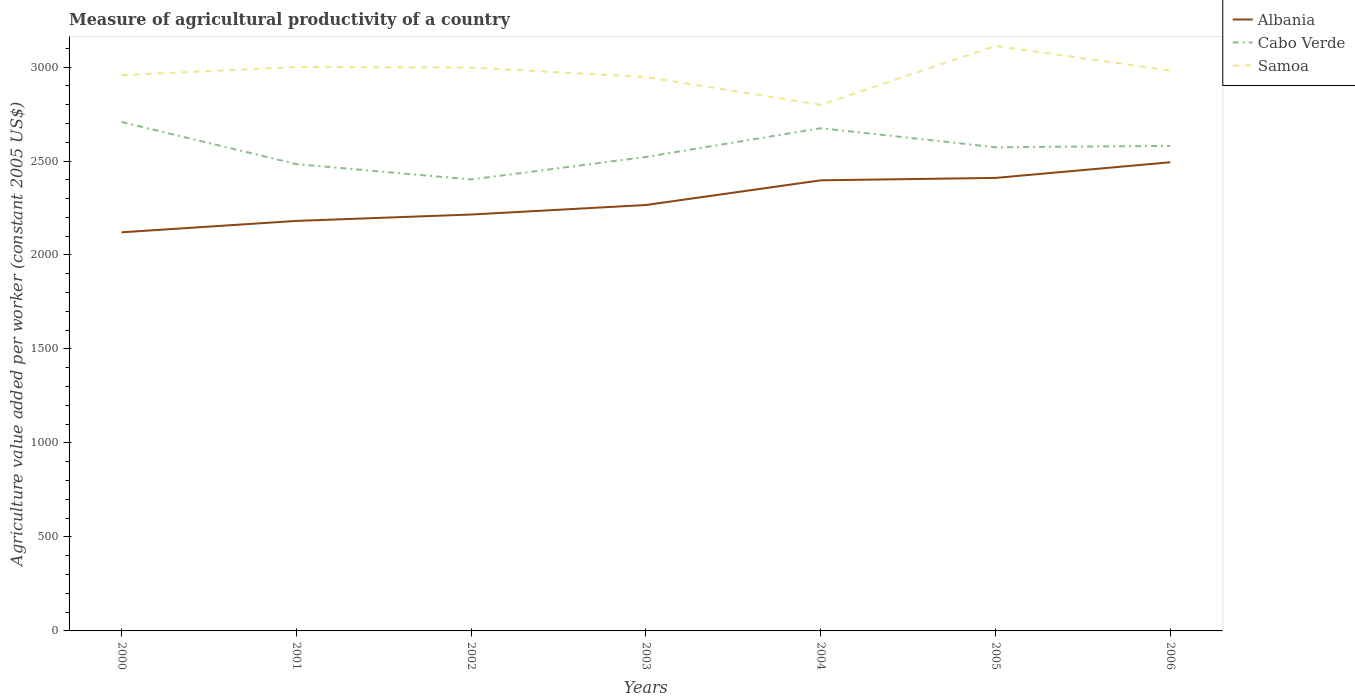Does the line corresponding to Samoa intersect with the line corresponding to Albania?
Keep it short and to the point. No. Across all years, what is the maximum measure of agricultural productivity in Albania?
Provide a short and direct response. 2120.67. What is the total measure of agricultural productivity in Cabo Verde in the graph?
Keep it short and to the point. 81.74. What is the difference between the highest and the second highest measure of agricultural productivity in Samoa?
Provide a short and direct response. 313.85. Is the measure of agricultural productivity in Samoa strictly greater than the measure of agricultural productivity in Albania over the years?
Provide a short and direct response. No. How many years are there in the graph?
Your answer should be very brief. 7. What is the difference between two consecutive major ticks on the Y-axis?
Keep it short and to the point. 500. Does the graph contain any zero values?
Your answer should be very brief. No. Does the graph contain grids?
Provide a short and direct response. No. Where does the legend appear in the graph?
Make the answer very short. Top right. How are the legend labels stacked?
Offer a terse response. Vertical. What is the title of the graph?
Your answer should be compact. Measure of agricultural productivity of a country. What is the label or title of the Y-axis?
Offer a very short reply. Agriculture value added per worker (constant 2005 US$). What is the Agriculture value added per worker (constant 2005 US$) of Albania in 2000?
Make the answer very short. 2120.67. What is the Agriculture value added per worker (constant 2005 US$) of Cabo Verde in 2000?
Provide a succinct answer. 2707.6. What is the Agriculture value added per worker (constant 2005 US$) of Samoa in 2000?
Offer a terse response. 2956.46. What is the Agriculture value added per worker (constant 2005 US$) of Albania in 2001?
Make the answer very short. 2181.33. What is the Agriculture value added per worker (constant 2005 US$) of Cabo Verde in 2001?
Your response must be concise. 2483.66. What is the Agriculture value added per worker (constant 2005 US$) of Samoa in 2001?
Make the answer very short. 3000.37. What is the Agriculture value added per worker (constant 2005 US$) in Albania in 2002?
Give a very brief answer. 2215.33. What is the Agriculture value added per worker (constant 2005 US$) of Cabo Verde in 2002?
Ensure brevity in your answer.  2401.92. What is the Agriculture value added per worker (constant 2005 US$) in Samoa in 2002?
Provide a short and direct response. 2997.24. What is the Agriculture value added per worker (constant 2005 US$) of Albania in 2003?
Your answer should be very brief. 2265.96. What is the Agriculture value added per worker (constant 2005 US$) of Cabo Verde in 2003?
Your response must be concise. 2521.55. What is the Agriculture value added per worker (constant 2005 US$) in Samoa in 2003?
Give a very brief answer. 2946.98. What is the Agriculture value added per worker (constant 2005 US$) in Albania in 2004?
Your answer should be very brief. 2397.31. What is the Agriculture value added per worker (constant 2005 US$) in Cabo Verde in 2004?
Provide a short and direct response. 2674.6. What is the Agriculture value added per worker (constant 2005 US$) of Samoa in 2004?
Keep it short and to the point. 2798.62. What is the Agriculture value added per worker (constant 2005 US$) in Albania in 2005?
Offer a terse response. 2410.11. What is the Agriculture value added per worker (constant 2005 US$) of Cabo Verde in 2005?
Ensure brevity in your answer.  2573.22. What is the Agriculture value added per worker (constant 2005 US$) in Samoa in 2005?
Offer a very short reply. 3112.47. What is the Agriculture value added per worker (constant 2005 US$) in Albania in 2006?
Provide a short and direct response. 2493.36. What is the Agriculture value added per worker (constant 2005 US$) of Cabo Verde in 2006?
Provide a succinct answer. 2580.54. What is the Agriculture value added per worker (constant 2005 US$) in Samoa in 2006?
Offer a very short reply. 2980.96. Across all years, what is the maximum Agriculture value added per worker (constant 2005 US$) of Albania?
Keep it short and to the point. 2493.36. Across all years, what is the maximum Agriculture value added per worker (constant 2005 US$) in Cabo Verde?
Provide a succinct answer. 2707.6. Across all years, what is the maximum Agriculture value added per worker (constant 2005 US$) of Samoa?
Offer a terse response. 3112.47. Across all years, what is the minimum Agriculture value added per worker (constant 2005 US$) in Albania?
Offer a very short reply. 2120.67. Across all years, what is the minimum Agriculture value added per worker (constant 2005 US$) of Cabo Verde?
Provide a succinct answer. 2401.92. Across all years, what is the minimum Agriculture value added per worker (constant 2005 US$) of Samoa?
Provide a short and direct response. 2798.62. What is the total Agriculture value added per worker (constant 2005 US$) of Albania in the graph?
Offer a terse response. 1.61e+04. What is the total Agriculture value added per worker (constant 2005 US$) of Cabo Verde in the graph?
Provide a short and direct response. 1.79e+04. What is the total Agriculture value added per worker (constant 2005 US$) of Samoa in the graph?
Provide a succinct answer. 2.08e+04. What is the difference between the Agriculture value added per worker (constant 2005 US$) of Albania in 2000 and that in 2001?
Ensure brevity in your answer.  -60.67. What is the difference between the Agriculture value added per worker (constant 2005 US$) in Cabo Verde in 2000 and that in 2001?
Offer a very short reply. 223.94. What is the difference between the Agriculture value added per worker (constant 2005 US$) in Samoa in 2000 and that in 2001?
Your answer should be very brief. -43.91. What is the difference between the Agriculture value added per worker (constant 2005 US$) of Albania in 2000 and that in 2002?
Your response must be concise. -94.66. What is the difference between the Agriculture value added per worker (constant 2005 US$) in Cabo Verde in 2000 and that in 2002?
Provide a succinct answer. 305.69. What is the difference between the Agriculture value added per worker (constant 2005 US$) in Samoa in 2000 and that in 2002?
Give a very brief answer. -40.78. What is the difference between the Agriculture value added per worker (constant 2005 US$) of Albania in 2000 and that in 2003?
Give a very brief answer. -145.3. What is the difference between the Agriculture value added per worker (constant 2005 US$) in Cabo Verde in 2000 and that in 2003?
Provide a succinct answer. 186.05. What is the difference between the Agriculture value added per worker (constant 2005 US$) in Samoa in 2000 and that in 2003?
Make the answer very short. 9.49. What is the difference between the Agriculture value added per worker (constant 2005 US$) in Albania in 2000 and that in 2004?
Your answer should be very brief. -276.64. What is the difference between the Agriculture value added per worker (constant 2005 US$) in Cabo Verde in 2000 and that in 2004?
Make the answer very short. 33.01. What is the difference between the Agriculture value added per worker (constant 2005 US$) of Samoa in 2000 and that in 2004?
Offer a terse response. 157.85. What is the difference between the Agriculture value added per worker (constant 2005 US$) in Albania in 2000 and that in 2005?
Make the answer very short. -289.45. What is the difference between the Agriculture value added per worker (constant 2005 US$) in Cabo Verde in 2000 and that in 2005?
Offer a terse response. 134.38. What is the difference between the Agriculture value added per worker (constant 2005 US$) in Samoa in 2000 and that in 2005?
Give a very brief answer. -156. What is the difference between the Agriculture value added per worker (constant 2005 US$) in Albania in 2000 and that in 2006?
Your answer should be very brief. -372.69. What is the difference between the Agriculture value added per worker (constant 2005 US$) of Cabo Verde in 2000 and that in 2006?
Your answer should be very brief. 127.06. What is the difference between the Agriculture value added per worker (constant 2005 US$) of Samoa in 2000 and that in 2006?
Make the answer very short. -24.49. What is the difference between the Agriculture value added per worker (constant 2005 US$) in Albania in 2001 and that in 2002?
Make the answer very short. -34. What is the difference between the Agriculture value added per worker (constant 2005 US$) in Cabo Verde in 2001 and that in 2002?
Make the answer very short. 81.74. What is the difference between the Agriculture value added per worker (constant 2005 US$) in Samoa in 2001 and that in 2002?
Offer a very short reply. 3.13. What is the difference between the Agriculture value added per worker (constant 2005 US$) of Albania in 2001 and that in 2003?
Your answer should be compact. -84.63. What is the difference between the Agriculture value added per worker (constant 2005 US$) in Cabo Verde in 2001 and that in 2003?
Give a very brief answer. -37.89. What is the difference between the Agriculture value added per worker (constant 2005 US$) of Samoa in 2001 and that in 2003?
Ensure brevity in your answer.  53.4. What is the difference between the Agriculture value added per worker (constant 2005 US$) in Albania in 2001 and that in 2004?
Your response must be concise. -215.97. What is the difference between the Agriculture value added per worker (constant 2005 US$) of Cabo Verde in 2001 and that in 2004?
Keep it short and to the point. -190.94. What is the difference between the Agriculture value added per worker (constant 2005 US$) in Samoa in 2001 and that in 2004?
Offer a very short reply. 201.76. What is the difference between the Agriculture value added per worker (constant 2005 US$) of Albania in 2001 and that in 2005?
Your answer should be compact. -228.78. What is the difference between the Agriculture value added per worker (constant 2005 US$) in Cabo Verde in 2001 and that in 2005?
Offer a very short reply. -89.56. What is the difference between the Agriculture value added per worker (constant 2005 US$) in Samoa in 2001 and that in 2005?
Ensure brevity in your answer.  -112.1. What is the difference between the Agriculture value added per worker (constant 2005 US$) in Albania in 2001 and that in 2006?
Make the answer very short. -312.02. What is the difference between the Agriculture value added per worker (constant 2005 US$) of Cabo Verde in 2001 and that in 2006?
Give a very brief answer. -96.88. What is the difference between the Agriculture value added per worker (constant 2005 US$) of Samoa in 2001 and that in 2006?
Keep it short and to the point. 19.42. What is the difference between the Agriculture value added per worker (constant 2005 US$) of Albania in 2002 and that in 2003?
Provide a short and direct response. -50.63. What is the difference between the Agriculture value added per worker (constant 2005 US$) in Cabo Verde in 2002 and that in 2003?
Provide a short and direct response. -119.63. What is the difference between the Agriculture value added per worker (constant 2005 US$) in Samoa in 2002 and that in 2003?
Your answer should be compact. 50.26. What is the difference between the Agriculture value added per worker (constant 2005 US$) of Albania in 2002 and that in 2004?
Offer a very short reply. -181.98. What is the difference between the Agriculture value added per worker (constant 2005 US$) in Cabo Verde in 2002 and that in 2004?
Make the answer very short. -272.68. What is the difference between the Agriculture value added per worker (constant 2005 US$) of Samoa in 2002 and that in 2004?
Offer a very short reply. 198.62. What is the difference between the Agriculture value added per worker (constant 2005 US$) in Albania in 2002 and that in 2005?
Provide a succinct answer. -194.78. What is the difference between the Agriculture value added per worker (constant 2005 US$) of Cabo Verde in 2002 and that in 2005?
Provide a short and direct response. -171.3. What is the difference between the Agriculture value added per worker (constant 2005 US$) of Samoa in 2002 and that in 2005?
Your answer should be very brief. -115.23. What is the difference between the Agriculture value added per worker (constant 2005 US$) of Albania in 2002 and that in 2006?
Keep it short and to the point. -278.03. What is the difference between the Agriculture value added per worker (constant 2005 US$) in Cabo Verde in 2002 and that in 2006?
Provide a succinct answer. -178.62. What is the difference between the Agriculture value added per worker (constant 2005 US$) of Samoa in 2002 and that in 2006?
Make the answer very short. 16.28. What is the difference between the Agriculture value added per worker (constant 2005 US$) in Albania in 2003 and that in 2004?
Your response must be concise. -131.34. What is the difference between the Agriculture value added per worker (constant 2005 US$) of Cabo Verde in 2003 and that in 2004?
Your answer should be very brief. -153.05. What is the difference between the Agriculture value added per worker (constant 2005 US$) in Samoa in 2003 and that in 2004?
Provide a succinct answer. 148.36. What is the difference between the Agriculture value added per worker (constant 2005 US$) of Albania in 2003 and that in 2005?
Your answer should be very brief. -144.15. What is the difference between the Agriculture value added per worker (constant 2005 US$) in Cabo Verde in 2003 and that in 2005?
Your answer should be very brief. -51.67. What is the difference between the Agriculture value added per worker (constant 2005 US$) of Samoa in 2003 and that in 2005?
Give a very brief answer. -165.49. What is the difference between the Agriculture value added per worker (constant 2005 US$) of Albania in 2003 and that in 2006?
Your answer should be very brief. -227.39. What is the difference between the Agriculture value added per worker (constant 2005 US$) in Cabo Verde in 2003 and that in 2006?
Your answer should be very brief. -58.99. What is the difference between the Agriculture value added per worker (constant 2005 US$) of Samoa in 2003 and that in 2006?
Ensure brevity in your answer.  -33.98. What is the difference between the Agriculture value added per worker (constant 2005 US$) of Albania in 2004 and that in 2005?
Your answer should be very brief. -12.8. What is the difference between the Agriculture value added per worker (constant 2005 US$) in Cabo Verde in 2004 and that in 2005?
Your response must be concise. 101.38. What is the difference between the Agriculture value added per worker (constant 2005 US$) in Samoa in 2004 and that in 2005?
Your answer should be compact. -313.85. What is the difference between the Agriculture value added per worker (constant 2005 US$) in Albania in 2004 and that in 2006?
Ensure brevity in your answer.  -96.05. What is the difference between the Agriculture value added per worker (constant 2005 US$) of Cabo Verde in 2004 and that in 2006?
Give a very brief answer. 94.06. What is the difference between the Agriculture value added per worker (constant 2005 US$) of Samoa in 2004 and that in 2006?
Keep it short and to the point. -182.34. What is the difference between the Agriculture value added per worker (constant 2005 US$) of Albania in 2005 and that in 2006?
Keep it short and to the point. -83.24. What is the difference between the Agriculture value added per worker (constant 2005 US$) in Cabo Verde in 2005 and that in 2006?
Provide a succinct answer. -7.32. What is the difference between the Agriculture value added per worker (constant 2005 US$) of Samoa in 2005 and that in 2006?
Provide a succinct answer. 131.51. What is the difference between the Agriculture value added per worker (constant 2005 US$) in Albania in 2000 and the Agriculture value added per worker (constant 2005 US$) in Cabo Verde in 2001?
Offer a very short reply. -362.99. What is the difference between the Agriculture value added per worker (constant 2005 US$) in Albania in 2000 and the Agriculture value added per worker (constant 2005 US$) in Samoa in 2001?
Give a very brief answer. -879.71. What is the difference between the Agriculture value added per worker (constant 2005 US$) of Cabo Verde in 2000 and the Agriculture value added per worker (constant 2005 US$) of Samoa in 2001?
Ensure brevity in your answer.  -292.77. What is the difference between the Agriculture value added per worker (constant 2005 US$) of Albania in 2000 and the Agriculture value added per worker (constant 2005 US$) of Cabo Verde in 2002?
Your answer should be very brief. -281.25. What is the difference between the Agriculture value added per worker (constant 2005 US$) of Albania in 2000 and the Agriculture value added per worker (constant 2005 US$) of Samoa in 2002?
Ensure brevity in your answer.  -876.57. What is the difference between the Agriculture value added per worker (constant 2005 US$) of Cabo Verde in 2000 and the Agriculture value added per worker (constant 2005 US$) of Samoa in 2002?
Keep it short and to the point. -289.64. What is the difference between the Agriculture value added per worker (constant 2005 US$) of Albania in 2000 and the Agriculture value added per worker (constant 2005 US$) of Cabo Verde in 2003?
Make the answer very short. -400.88. What is the difference between the Agriculture value added per worker (constant 2005 US$) of Albania in 2000 and the Agriculture value added per worker (constant 2005 US$) of Samoa in 2003?
Your response must be concise. -826.31. What is the difference between the Agriculture value added per worker (constant 2005 US$) in Cabo Verde in 2000 and the Agriculture value added per worker (constant 2005 US$) in Samoa in 2003?
Your answer should be compact. -239.38. What is the difference between the Agriculture value added per worker (constant 2005 US$) in Albania in 2000 and the Agriculture value added per worker (constant 2005 US$) in Cabo Verde in 2004?
Provide a succinct answer. -553.93. What is the difference between the Agriculture value added per worker (constant 2005 US$) of Albania in 2000 and the Agriculture value added per worker (constant 2005 US$) of Samoa in 2004?
Offer a very short reply. -677.95. What is the difference between the Agriculture value added per worker (constant 2005 US$) in Cabo Verde in 2000 and the Agriculture value added per worker (constant 2005 US$) in Samoa in 2004?
Your answer should be very brief. -91.02. What is the difference between the Agriculture value added per worker (constant 2005 US$) in Albania in 2000 and the Agriculture value added per worker (constant 2005 US$) in Cabo Verde in 2005?
Offer a very short reply. -452.55. What is the difference between the Agriculture value added per worker (constant 2005 US$) of Albania in 2000 and the Agriculture value added per worker (constant 2005 US$) of Samoa in 2005?
Keep it short and to the point. -991.8. What is the difference between the Agriculture value added per worker (constant 2005 US$) in Cabo Verde in 2000 and the Agriculture value added per worker (constant 2005 US$) in Samoa in 2005?
Your response must be concise. -404.87. What is the difference between the Agriculture value added per worker (constant 2005 US$) in Albania in 2000 and the Agriculture value added per worker (constant 2005 US$) in Cabo Verde in 2006?
Ensure brevity in your answer.  -459.87. What is the difference between the Agriculture value added per worker (constant 2005 US$) in Albania in 2000 and the Agriculture value added per worker (constant 2005 US$) in Samoa in 2006?
Your answer should be very brief. -860.29. What is the difference between the Agriculture value added per worker (constant 2005 US$) of Cabo Verde in 2000 and the Agriculture value added per worker (constant 2005 US$) of Samoa in 2006?
Your response must be concise. -273.35. What is the difference between the Agriculture value added per worker (constant 2005 US$) of Albania in 2001 and the Agriculture value added per worker (constant 2005 US$) of Cabo Verde in 2002?
Offer a very short reply. -220.58. What is the difference between the Agriculture value added per worker (constant 2005 US$) in Albania in 2001 and the Agriculture value added per worker (constant 2005 US$) in Samoa in 2002?
Ensure brevity in your answer.  -815.91. What is the difference between the Agriculture value added per worker (constant 2005 US$) in Cabo Verde in 2001 and the Agriculture value added per worker (constant 2005 US$) in Samoa in 2002?
Make the answer very short. -513.58. What is the difference between the Agriculture value added per worker (constant 2005 US$) in Albania in 2001 and the Agriculture value added per worker (constant 2005 US$) in Cabo Verde in 2003?
Your response must be concise. -340.21. What is the difference between the Agriculture value added per worker (constant 2005 US$) in Albania in 2001 and the Agriculture value added per worker (constant 2005 US$) in Samoa in 2003?
Give a very brief answer. -765.64. What is the difference between the Agriculture value added per worker (constant 2005 US$) of Cabo Verde in 2001 and the Agriculture value added per worker (constant 2005 US$) of Samoa in 2003?
Provide a short and direct response. -463.32. What is the difference between the Agriculture value added per worker (constant 2005 US$) of Albania in 2001 and the Agriculture value added per worker (constant 2005 US$) of Cabo Verde in 2004?
Your response must be concise. -493.26. What is the difference between the Agriculture value added per worker (constant 2005 US$) of Albania in 2001 and the Agriculture value added per worker (constant 2005 US$) of Samoa in 2004?
Ensure brevity in your answer.  -617.28. What is the difference between the Agriculture value added per worker (constant 2005 US$) in Cabo Verde in 2001 and the Agriculture value added per worker (constant 2005 US$) in Samoa in 2004?
Make the answer very short. -314.96. What is the difference between the Agriculture value added per worker (constant 2005 US$) of Albania in 2001 and the Agriculture value added per worker (constant 2005 US$) of Cabo Verde in 2005?
Keep it short and to the point. -391.88. What is the difference between the Agriculture value added per worker (constant 2005 US$) of Albania in 2001 and the Agriculture value added per worker (constant 2005 US$) of Samoa in 2005?
Provide a short and direct response. -931.13. What is the difference between the Agriculture value added per worker (constant 2005 US$) of Cabo Verde in 2001 and the Agriculture value added per worker (constant 2005 US$) of Samoa in 2005?
Your answer should be very brief. -628.81. What is the difference between the Agriculture value added per worker (constant 2005 US$) in Albania in 2001 and the Agriculture value added per worker (constant 2005 US$) in Cabo Verde in 2006?
Ensure brevity in your answer.  -399.2. What is the difference between the Agriculture value added per worker (constant 2005 US$) of Albania in 2001 and the Agriculture value added per worker (constant 2005 US$) of Samoa in 2006?
Provide a succinct answer. -799.62. What is the difference between the Agriculture value added per worker (constant 2005 US$) of Cabo Verde in 2001 and the Agriculture value added per worker (constant 2005 US$) of Samoa in 2006?
Your answer should be compact. -497.3. What is the difference between the Agriculture value added per worker (constant 2005 US$) in Albania in 2002 and the Agriculture value added per worker (constant 2005 US$) in Cabo Verde in 2003?
Make the answer very short. -306.22. What is the difference between the Agriculture value added per worker (constant 2005 US$) in Albania in 2002 and the Agriculture value added per worker (constant 2005 US$) in Samoa in 2003?
Your answer should be very brief. -731.65. What is the difference between the Agriculture value added per worker (constant 2005 US$) in Cabo Verde in 2002 and the Agriculture value added per worker (constant 2005 US$) in Samoa in 2003?
Provide a succinct answer. -545.06. What is the difference between the Agriculture value added per worker (constant 2005 US$) in Albania in 2002 and the Agriculture value added per worker (constant 2005 US$) in Cabo Verde in 2004?
Offer a terse response. -459.26. What is the difference between the Agriculture value added per worker (constant 2005 US$) of Albania in 2002 and the Agriculture value added per worker (constant 2005 US$) of Samoa in 2004?
Give a very brief answer. -583.29. What is the difference between the Agriculture value added per worker (constant 2005 US$) of Cabo Verde in 2002 and the Agriculture value added per worker (constant 2005 US$) of Samoa in 2004?
Your answer should be very brief. -396.7. What is the difference between the Agriculture value added per worker (constant 2005 US$) of Albania in 2002 and the Agriculture value added per worker (constant 2005 US$) of Cabo Verde in 2005?
Your answer should be very brief. -357.89. What is the difference between the Agriculture value added per worker (constant 2005 US$) of Albania in 2002 and the Agriculture value added per worker (constant 2005 US$) of Samoa in 2005?
Your answer should be very brief. -897.14. What is the difference between the Agriculture value added per worker (constant 2005 US$) in Cabo Verde in 2002 and the Agriculture value added per worker (constant 2005 US$) in Samoa in 2005?
Offer a terse response. -710.55. What is the difference between the Agriculture value added per worker (constant 2005 US$) of Albania in 2002 and the Agriculture value added per worker (constant 2005 US$) of Cabo Verde in 2006?
Give a very brief answer. -365.21. What is the difference between the Agriculture value added per worker (constant 2005 US$) in Albania in 2002 and the Agriculture value added per worker (constant 2005 US$) in Samoa in 2006?
Your answer should be compact. -765.62. What is the difference between the Agriculture value added per worker (constant 2005 US$) of Cabo Verde in 2002 and the Agriculture value added per worker (constant 2005 US$) of Samoa in 2006?
Your response must be concise. -579.04. What is the difference between the Agriculture value added per worker (constant 2005 US$) in Albania in 2003 and the Agriculture value added per worker (constant 2005 US$) in Cabo Verde in 2004?
Provide a succinct answer. -408.63. What is the difference between the Agriculture value added per worker (constant 2005 US$) of Albania in 2003 and the Agriculture value added per worker (constant 2005 US$) of Samoa in 2004?
Ensure brevity in your answer.  -532.65. What is the difference between the Agriculture value added per worker (constant 2005 US$) of Cabo Verde in 2003 and the Agriculture value added per worker (constant 2005 US$) of Samoa in 2004?
Make the answer very short. -277.07. What is the difference between the Agriculture value added per worker (constant 2005 US$) in Albania in 2003 and the Agriculture value added per worker (constant 2005 US$) in Cabo Verde in 2005?
Make the answer very short. -307.26. What is the difference between the Agriculture value added per worker (constant 2005 US$) of Albania in 2003 and the Agriculture value added per worker (constant 2005 US$) of Samoa in 2005?
Ensure brevity in your answer.  -846.51. What is the difference between the Agriculture value added per worker (constant 2005 US$) of Cabo Verde in 2003 and the Agriculture value added per worker (constant 2005 US$) of Samoa in 2005?
Make the answer very short. -590.92. What is the difference between the Agriculture value added per worker (constant 2005 US$) in Albania in 2003 and the Agriculture value added per worker (constant 2005 US$) in Cabo Verde in 2006?
Offer a very short reply. -314.57. What is the difference between the Agriculture value added per worker (constant 2005 US$) of Albania in 2003 and the Agriculture value added per worker (constant 2005 US$) of Samoa in 2006?
Your answer should be very brief. -714.99. What is the difference between the Agriculture value added per worker (constant 2005 US$) in Cabo Verde in 2003 and the Agriculture value added per worker (constant 2005 US$) in Samoa in 2006?
Your answer should be compact. -459.41. What is the difference between the Agriculture value added per worker (constant 2005 US$) in Albania in 2004 and the Agriculture value added per worker (constant 2005 US$) in Cabo Verde in 2005?
Your answer should be compact. -175.91. What is the difference between the Agriculture value added per worker (constant 2005 US$) in Albania in 2004 and the Agriculture value added per worker (constant 2005 US$) in Samoa in 2005?
Offer a terse response. -715.16. What is the difference between the Agriculture value added per worker (constant 2005 US$) of Cabo Verde in 2004 and the Agriculture value added per worker (constant 2005 US$) of Samoa in 2005?
Provide a succinct answer. -437.87. What is the difference between the Agriculture value added per worker (constant 2005 US$) in Albania in 2004 and the Agriculture value added per worker (constant 2005 US$) in Cabo Verde in 2006?
Keep it short and to the point. -183.23. What is the difference between the Agriculture value added per worker (constant 2005 US$) of Albania in 2004 and the Agriculture value added per worker (constant 2005 US$) of Samoa in 2006?
Make the answer very short. -583.65. What is the difference between the Agriculture value added per worker (constant 2005 US$) in Cabo Verde in 2004 and the Agriculture value added per worker (constant 2005 US$) in Samoa in 2006?
Give a very brief answer. -306.36. What is the difference between the Agriculture value added per worker (constant 2005 US$) in Albania in 2005 and the Agriculture value added per worker (constant 2005 US$) in Cabo Verde in 2006?
Give a very brief answer. -170.42. What is the difference between the Agriculture value added per worker (constant 2005 US$) in Albania in 2005 and the Agriculture value added per worker (constant 2005 US$) in Samoa in 2006?
Your answer should be compact. -570.84. What is the difference between the Agriculture value added per worker (constant 2005 US$) of Cabo Verde in 2005 and the Agriculture value added per worker (constant 2005 US$) of Samoa in 2006?
Your answer should be very brief. -407.74. What is the average Agriculture value added per worker (constant 2005 US$) of Albania per year?
Make the answer very short. 2297.73. What is the average Agriculture value added per worker (constant 2005 US$) in Cabo Verde per year?
Offer a terse response. 2563.3. What is the average Agriculture value added per worker (constant 2005 US$) of Samoa per year?
Your answer should be very brief. 2970.44. In the year 2000, what is the difference between the Agriculture value added per worker (constant 2005 US$) of Albania and Agriculture value added per worker (constant 2005 US$) of Cabo Verde?
Offer a very short reply. -586.93. In the year 2000, what is the difference between the Agriculture value added per worker (constant 2005 US$) in Albania and Agriculture value added per worker (constant 2005 US$) in Samoa?
Your answer should be compact. -835.8. In the year 2000, what is the difference between the Agriculture value added per worker (constant 2005 US$) in Cabo Verde and Agriculture value added per worker (constant 2005 US$) in Samoa?
Ensure brevity in your answer.  -248.86. In the year 2001, what is the difference between the Agriculture value added per worker (constant 2005 US$) of Albania and Agriculture value added per worker (constant 2005 US$) of Cabo Verde?
Give a very brief answer. -302.32. In the year 2001, what is the difference between the Agriculture value added per worker (constant 2005 US$) of Albania and Agriculture value added per worker (constant 2005 US$) of Samoa?
Your answer should be compact. -819.04. In the year 2001, what is the difference between the Agriculture value added per worker (constant 2005 US$) of Cabo Verde and Agriculture value added per worker (constant 2005 US$) of Samoa?
Offer a terse response. -516.72. In the year 2002, what is the difference between the Agriculture value added per worker (constant 2005 US$) of Albania and Agriculture value added per worker (constant 2005 US$) of Cabo Verde?
Offer a very short reply. -186.58. In the year 2002, what is the difference between the Agriculture value added per worker (constant 2005 US$) in Albania and Agriculture value added per worker (constant 2005 US$) in Samoa?
Ensure brevity in your answer.  -781.91. In the year 2002, what is the difference between the Agriculture value added per worker (constant 2005 US$) of Cabo Verde and Agriculture value added per worker (constant 2005 US$) of Samoa?
Offer a terse response. -595.33. In the year 2003, what is the difference between the Agriculture value added per worker (constant 2005 US$) of Albania and Agriculture value added per worker (constant 2005 US$) of Cabo Verde?
Provide a short and direct response. -255.58. In the year 2003, what is the difference between the Agriculture value added per worker (constant 2005 US$) in Albania and Agriculture value added per worker (constant 2005 US$) in Samoa?
Offer a very short reply. -681.01. In the year 2003, what is the difference between the Agriculture value added per worker (constant 2005 US$) of Cabo Verde and Agriculture value added per worker (constant 2005 US$) of Samoa?
Ensure brevity in your answer.  -425.43. In the year 2004, what is the difference between the Agriculture value added per worker (constant 2005 US$) in Albania and Agriculture value added per worker (constant 2005 US$) in Cabo Verde?
Your answer should be very brief. -277.29. In the year 2004, what is the difference between the Agriculture value added per worker (constant 2005 US$) of Albania and Agriculture value added per worker (constant 2005 US$) of Samoa?
Give a very brief answer. -401.31. In the year 2004, what is the difference between the Agriculture value added per worker (constant 2005 US$) in Cabo Verde and Agriculture value added per worker (constant 2005 US$) in Samoa?
Provide a short and direct response. -124.02. In the year 2005, what is the difference between the Agriculture value added per worker (constant 2005 US$) in Albania and Agriculture value added per worker (constant 2005 US$) in Cabo Verde?
Make the answer very short. -163.11. In the year 2005, what is the difference between the Agriculture value added per worker (constant 2005 US$) of Albania and Agriculture value added per worker (constant 2005 US$) of Samoa?
Make the answer very short. -702.36. In the year 2005, what is the difference between the Agriculture value added per worker (constant 2005 US$) of Cabo Verde and Agriculture value added per worker (constant 2005 US$) of Samoa?
Provide a short and direct response. -539.25. In the year 2006, what is the difference between the Agriculture value added per worker (constant 2005 US$) of Albania and Agriculture value added per worker (constant 2005 US$) of Cabo Verde?
Provide a succinct answer. -87.18. In the year 2006, what is the difference between the Agriculture value added per worker (constant 2005 US$) in Albania and Agriculture value added per worker (constant 2005 US$) in Samoa?
Your response must be concise. -487.6. In the year 2006, what is the difference between the Agriculture value added per worker (constant 2005 US$) in Cabo Verde and Agriculture value added per worker (constant 2005 US$) in Samoa?
Offer a very short reply. -400.42. What is the ratio of the Agriculture value added per worker (constant 2005 US$) in Albania in 2000 to that in 2001?
Keep it short and to the point. 0.97. What is the ratio of the Agriculture value added per worker (constant 2005 US$) in Cabo Verde in 2000 to that in 2001?
Make the answer very short. 1.09. What is the ratio of the Agriculture value added per worker (constant 2005 US$) of Samoa in 2000 to that in 2001?
Your answer should be compact. 0.99. What is the ratio of the Agriculture value added per worker (constant 2005 US$) of Albania in 2000 to that in 2002?
Ensure brevity in your answer.  0.96. What is the ratio of the Agriculture value added per worker (constant 2005 US$) of Cabo Verde in 2000 to that in 2002?
Ensure brevity in your answer.  1.13. What is the ratio of the Agriculture value added per worker (constant 2005 US$) in Samoa in 2000 to that in 2002?
Provide a short and direct response. 0.99. What is the ratio of the Agriculture value added per worker (constant 2005 US$) of Albania in 2000 to that in 2003?
Offer a very short reply. 0.94. What is the ratio of the Agriculture value added per worker (constant 2005 US$) in Cabo Verde in 2000 to that in 2003?
Your answer should be very brief. 1.07. What is the ratio of the Agriculture value added per worker (constant 2005 US$) in Samoa in 2000 to that in 2003?
Your answer should be very brief. 1. What is the ratio of the Agriculture value added per worker (constant 2005 US$) of Albania in 2000 to that in 2004?
Your response must be concise. 0.88. What is the ratio of the Agriculture value added per worker (constant 2005 US$) of Cabo Verde in 2000 to that in 2004?
Make the answer very short. 1.01. What is the ratio of the Agriculture value added per worker (constant 2005 US$) in Samoa in 2000 to that in 2004?
Offer a very short reply. 1.06. What is the ratio of the Agriculture value added per worker (constant 2005 US$) of Albania in 2000 to that in 2005?
Keep it short and to the point. 0.88. What is the ratio of the Agriculture value added per worker (constant 2005 US$) in Cabo Verde in 2000 to that in 2005?
Provide a short and direct response. 1.05. What is the ratio of the Agriculture value added per worker (constant 2005 US$) of Samoa in 2000 to that in 2005?
Ensure brevity in your answer.  0.95. What is the ratio of the Agriculture value added per worker (constant 2005 US$) of Albania in 2000 to that in 2006?
Your answer should be very brief. 0.85. What is the ratio of the Agriculture value added per worker (constant 2005 US$) in Cabo Verde in 2000 to that in 2006?
Provide a succinct answer. 1.05. What is the ratio of the Agriculture value added per worker (constant 2005 US$) in Samoa in 2000 to that in 2006?
Offer a very short reply. 0.99. What is the ratio of the Agriculture value added per worker (constant 2005 US$) of Albania in 2001 to that in 2002?
Make the answer very short. 0.98. What is the ratio of the Agriculture value added per worker (constant 2005 US$) in Cabo Verde in 2001 to that in 2002?
Offer a very short reply. 1.03. What is the ratio of the Agriculture value added per worker (constant 2005 US$) of Samoa in 2001 to that in 2002?
Give a very brief answer. 1. What is the ratio of the Agriculture value added per worker (constant 2005 US$) in Albania in 2001 to that in 2003?
Your response must be concise. 0.96. What is the ratio of the Agriculture value added per worker (constant 2005 US$) in Samoa in 2001 to that in 2003?
Provide a succinct answer. 1.02. What is the ratio of the Agriculture value added per worker (constant 2005 US$) in Albania in 2001 to that in 2004?
Give a very brief answer. 0.91. What is the ratio of the Agriculture value added per worker (constant 2005 US$) in Cabo Verde in 2001 to that in 2004?
Your answer should be compact. 0.93. What is the ratio of the Agriculture value added per worker (constant 2005 US$) of Samoa in 2001 to that in 2004?
Provide a short and direct response. 1.07. What is the ratio of the Agriculture value added per worker (constant 2005 US$) in Albania in 2001 to that in 2005?
Keep it short and to the point. 0.91. What is the ratio of the Agriculture value added per worker (constant 2005 US$) in Cabo Verde in 2001 to that in 2005?
Offer a very short reply. 0.97. What is the ratio of the Agriculture value added per worker (constant 2005 US$) of Albania in 2001 to that in 2006?
Your answer should be compact. 0.87. What is the ratio of the Agriculture value added per worker (constant 2005 US$) of Cabo Verde in 2001 to that in 2006?
Provide a succinct answer. 0.96. What is the ratio of the Agriculture value added per worker (constant 2005 US$) in Samoa in 2001 to that in 2006?
Your answer should be compact. 1.01. What is the ratio of the Agriculture value added per worker (constant 2005 US$) in Albania in 2002 to that in 2003?
Make the answer very short. 0.98. What is the ratio of the Agriculture value added per worker (constant 2005 US$) in Cabo Verde in 2002 to that in 2003?
Make the answer very short. 0.95. What is the ratio of the Agriculture value added per worker (constant 2005 US$) in Samoa in 2002 to that in 2003?
Your response must be concise. 1.02. What is the ratio of the Agriculture value added per worker (constant 2005 US$) in Albania in 2002 to that in 2004?
Your answer should be very brief. 0.92. What is the ratio of the Agriculture value added per worker (constant 2005 US$) in Cabo Verde in 2002 to that in 2004?
Make the answer very short. 0.9. What is the ratio of the Agriculture value added per worker (constant 2005 US$) in Samoa in 2002 to that in 2004?
Provide a succinct answer. 1.07. What is the ratio of the Agriculture value added per worker (constant 2005 US$) in Albania in 2002 to that in 2005?
Offer a very short reply. 0.92. What is the ratio of the Agriculture value added per worker (constant 2005 US$) of Cabo Verde in 2002 to that in 2005?
Your answer should be very brief. 0.93. What is the ratio of the Agriculture value added per worker (constant 2005 US$) in Samoa in 2002 to that in 2005?
Provide a succinct answer. 0.96. What is the ratio of the Agriculture value added per worker (constant 2005 US$) of Albania in 2002 to that in 2006?
Offer a terse response. 0.89. What is the ratio of the Agriculture value added per worker (constant 2005 US$) in Cabo Verde in 2002 to that in 2006?
Make the answer very short. 0.93. What is the ratio of the Agriculture value added per worker (constant 2005 US$) of Samoa in 2002 to that in 2006?
Make the answer very short. 1.01. What is the ratio of the Agriculture value added per worker (constant 2005 US$) in Albania in 2003 to that in 2004?
Make the answer very short. 0.95. What is the ratio of the Agriculture value added per worker (constant 2005 US$) of Cabo Verde in 2003 to that in 2004?
Provide a short and direct response. 0.94. What is the ratio of the Agriculture value added per worker (constant 2005 US$) in Samoa in 2003 to that in 2004?
Your answer should be very brief. 1.05. What is the ratio of the Agriculture value added per worker (constant 2005 US$) of Albania in 2003 to that in 2005?
Your answer should be compact. 0.94. What is the ratio of the Agriculture value added per worker (constant 2005 US$) in Cabo Verde in 2003 to that in 2005?
Provide a succinct answer. 0.98. What is the ratio of the Agriculture value added per worker (constant 2005 US$) of Samoa in 2003 to that in 2005?
Make the answer very short. 0.95. What is the ratio of the Agriculture value added per worker (constant 2005 US$) in Albania in 2003 to that in 2006?
Offer a very short reply. 0.91. What is the ratio of the Agriculture value added per worker (constant 2005 US$) in Cabo Verde in 2003 to that in 2006?
Your response must be concise. 0.98. What is the ratio of the Agriculture value added per worker (constant 2005 US$) in Cabo Verde in 2004 to that in 2005?
Your response must be concise. 1.04. What is the ratio of the Agriculture value added per worker (constant 2005 US$) of Samoa in 2004 to that in 2005?
Offer a very short reply. 0.9. What is the ratio of the Agriculture value added per worker (constant 2005 US$) of Albania in 2004 to that in 2006?
Provide a succinct answer. 0.96. What is the ratio of the Agriculture value added per worker (constant 2005 US$) in Cabo Verde in 2004 to that in 2006?
Ensure brevity in your answer.  1.04. What is the ratio of the Agriculture value added per worker (constant 2005 US$) in Samoa in 2004 to that in 2006?
Give a very brief answer. 0.94. What is the ratio of the Agriculture value added per worker (constant 2005 US$) in Albania in 2005 to that in 2006?
Keep it short and to the point. 0.97. What is the ratio of the Agriculture value added per worker (constant 2005 US$) of Cabo Verde in 2005 to that in 2006?
Make the answer very short. 1. What is the ratio of the Agriculture value added per worker (constant 2005 US$) in Samoa in 2005 to that in 2006?
Your answer should be very brief. 1.04. What is the difference between the highest and the second highest Agriculture value added per worker (constant 2005 US$) of Albania?
Give a very brief answer. 83.24. What is the difference between the highest and the second highest Agriculture value added per worker (constant 2005 US$) in Cabo Verde?
Your response must be concise. 33.01. What is the difference between the highest and the second highest Agriculture value added per worker (constant 2005 US$) in Samoa?
Provide a succinct answer. 112.1. What is the difference between the highest and the lowest Agriculture value added per worker (constant 2005 US$) of Albania?
Offer a terse response. 372.69. What is the difference between the highest and the lowest Agriculture value added per worker (constant 2005 US$) of Cabo Verde?
Provide a short and direct response. 305.69. What is the difference between the highest and the lowest Agriculture value added per worker (constant 2005 US$) in Samoa?
Ensure brevity in your answer.  313.85. 